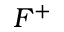Convert formula to latex. <formula><loc_0><loc_0><loc_500><loc_500>F ^ { + }</formula> 